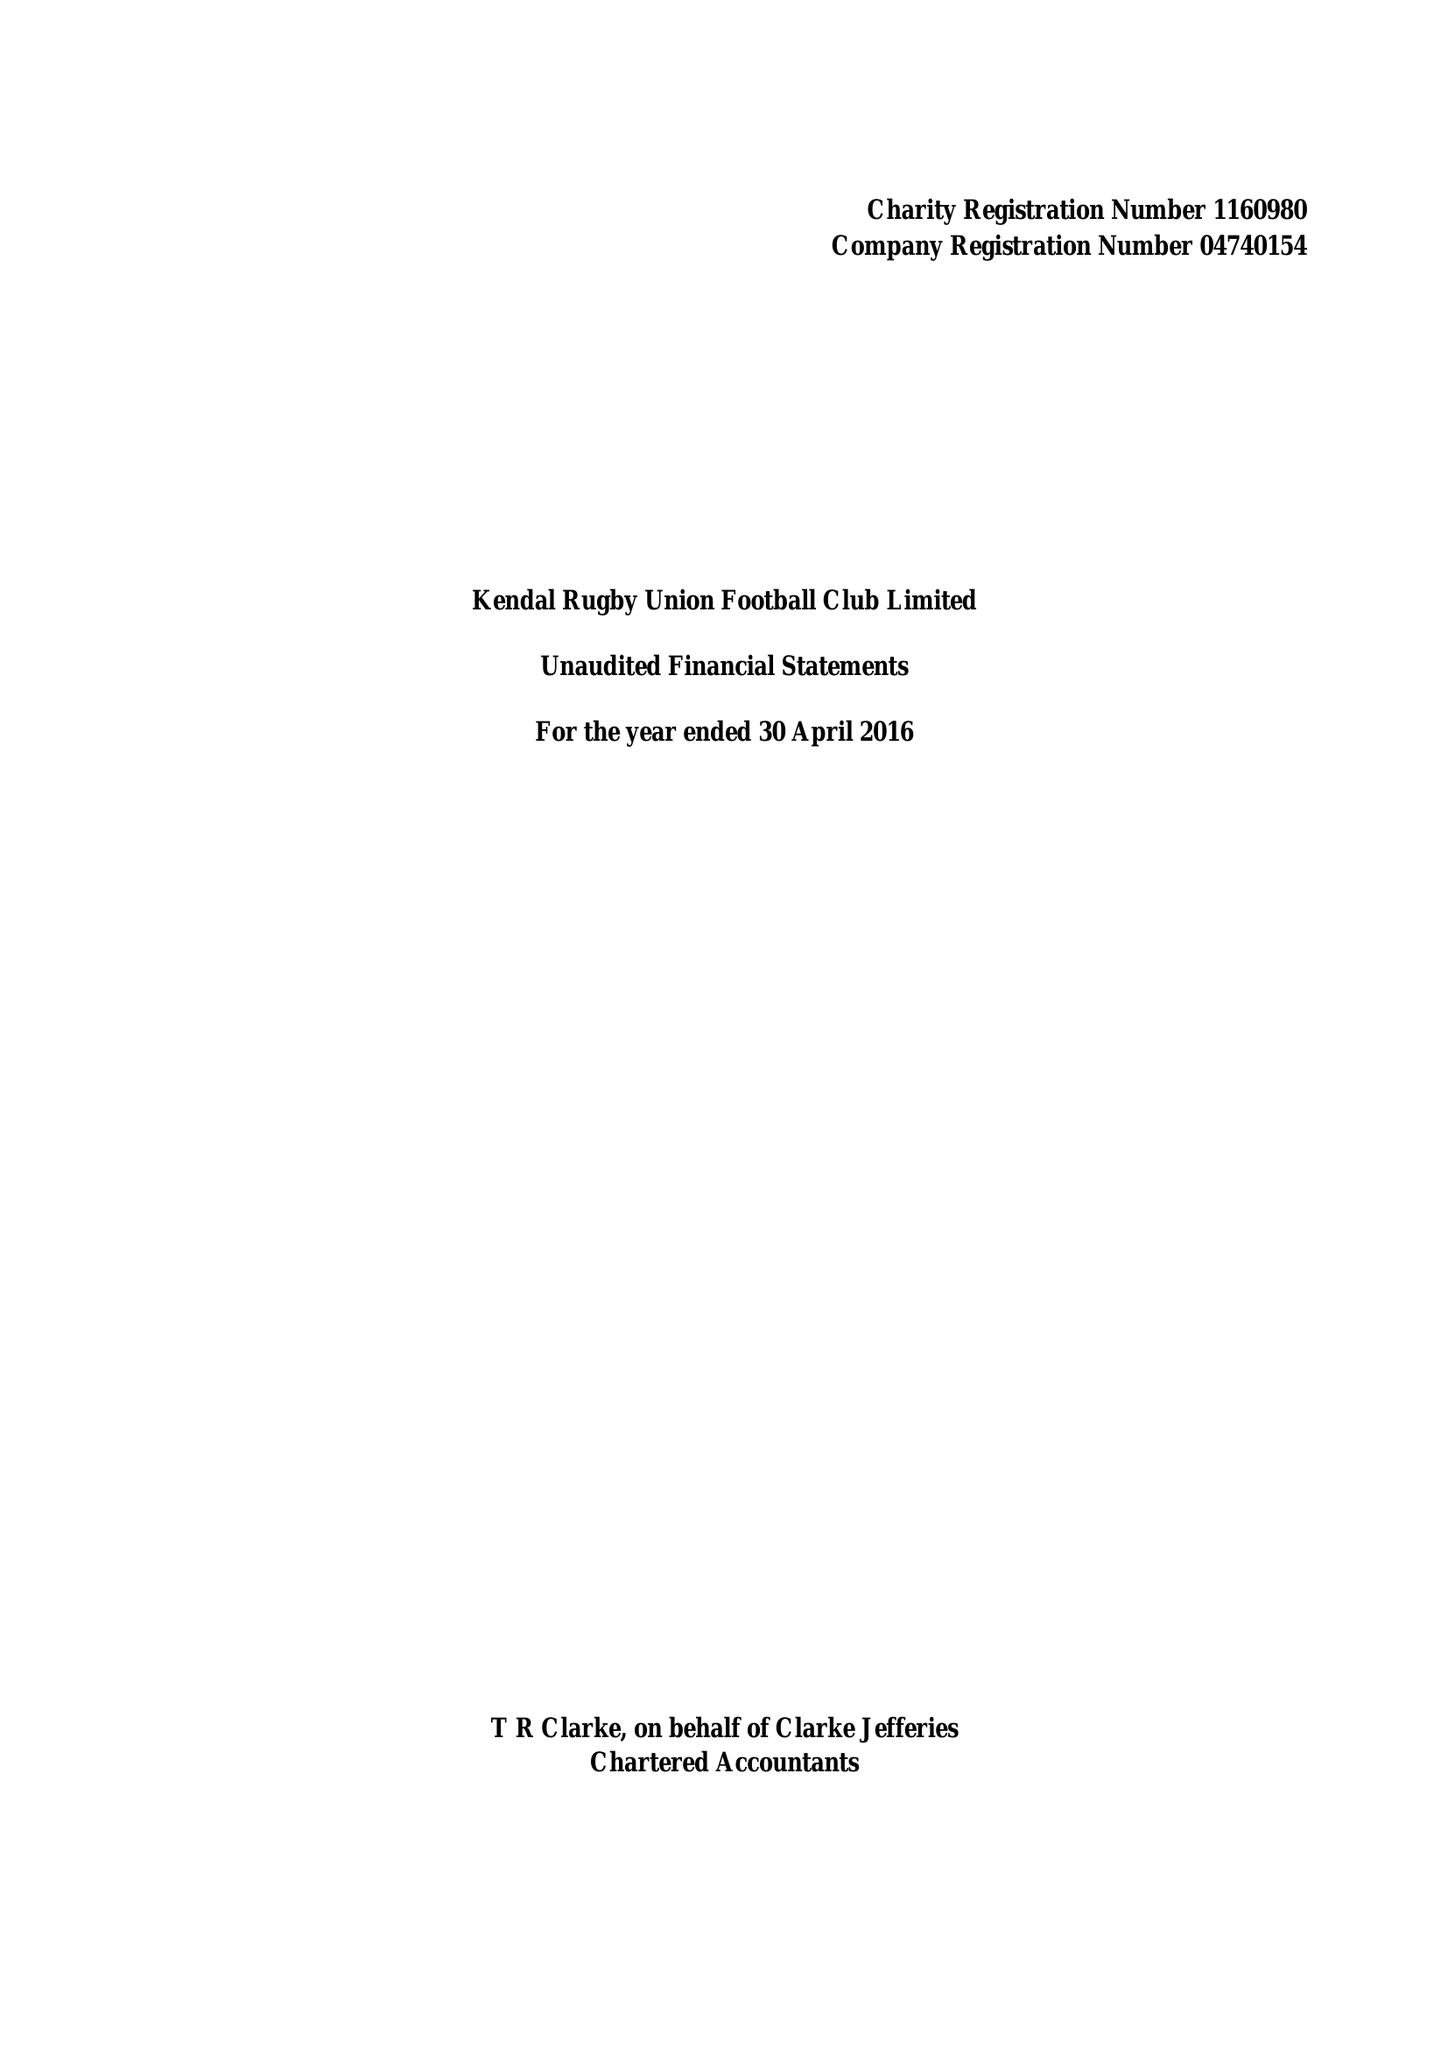What is the value for the address__street_line?
Answer the question using a single word or phrase. SHAP ROAD 